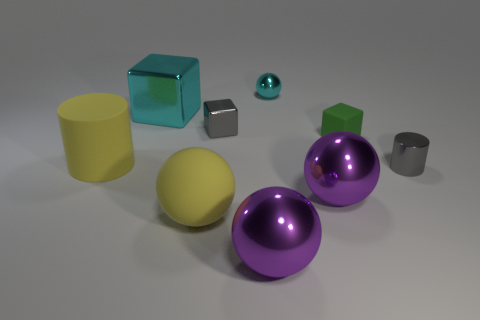Subtract all small shiny blocks. How many blocks are left? 2 Subtract all gray cylinders. How many purple balls are left? 2 Subtract all cyan blocks. How many blocks are left? 2 Subtract all blocks. How many objects are left? 6 Add 5 small green rubber cubes. How many small green rubber cubes exist? 6 Subtract 1 green blocks. How many objects are left? 8 Subtract 1 cylinders. How many cylinders are left? 1 Subtract all purple cubes. Subtract all purple cylinders. How many cubes are left? 3 Subtract all cyan metal cylinders. Subtract all gray objects. How many objects are left? 7 Add 3 rubber cubes. How many rubber cubes are left? 4 